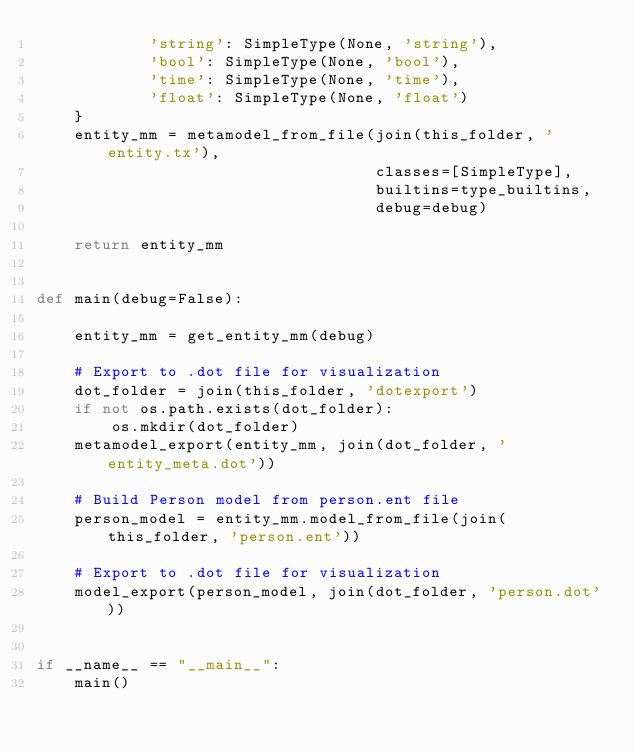<code> <loc_0><loc_0><loc_500><loc_500><_Python_>            'string': SimpleType(None, 'string'),
            'bool': SimpleType(None, 'bool'),
            'time': SimpleType(None, 'time'),
            'float': SimpleType(None, 'float')
    }
    entity_mm = metamodel_from_file(join(this_folder, 'entity.tx'),
                                    classes=[SimpleType],
                                    builtins=type_builtins,
                                    debug=debug)

    return entity_mm


def main(debug=False):

    entity_mm = get_entity_mm(debug)

    # Export to .dot file for visualization
    dot_folder = join(this_folder, 'dotexport')
    if not os.path.exists(dot_folder):
        os.mkdir(dot_folder)
    metamodel_export(entity_mm, join(dot_folder, 'entity_meta.dot'))

    # Build Person model from person.ent file
    person_model = entity_mm.model_from_file(join(this_folder, 'person.ent'))

    # Export to .dot file for visualization
    model_export(person_model, join(dot_folder, 'person.dot'))


if __name__ == "__main__":
    main()
</code> 